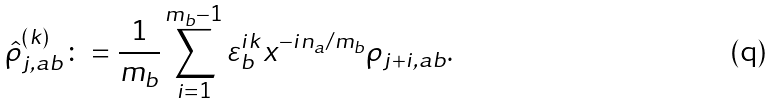Convert formula to latex. <formula><loc_0><loc_0><loc_500><loc_500>\hat { \rho } ^ { ( k ) } _ { j , a b } \colon = \frac { 1 } { m _ { b } } \sum _ { i = 1 } ^ { m _ { b } - 1 } \varepsilon _ { b } ^ { i k } x ^ { - i n _ { a } / m _ { b } } \rho _ { j + i , a b } .</formula> 